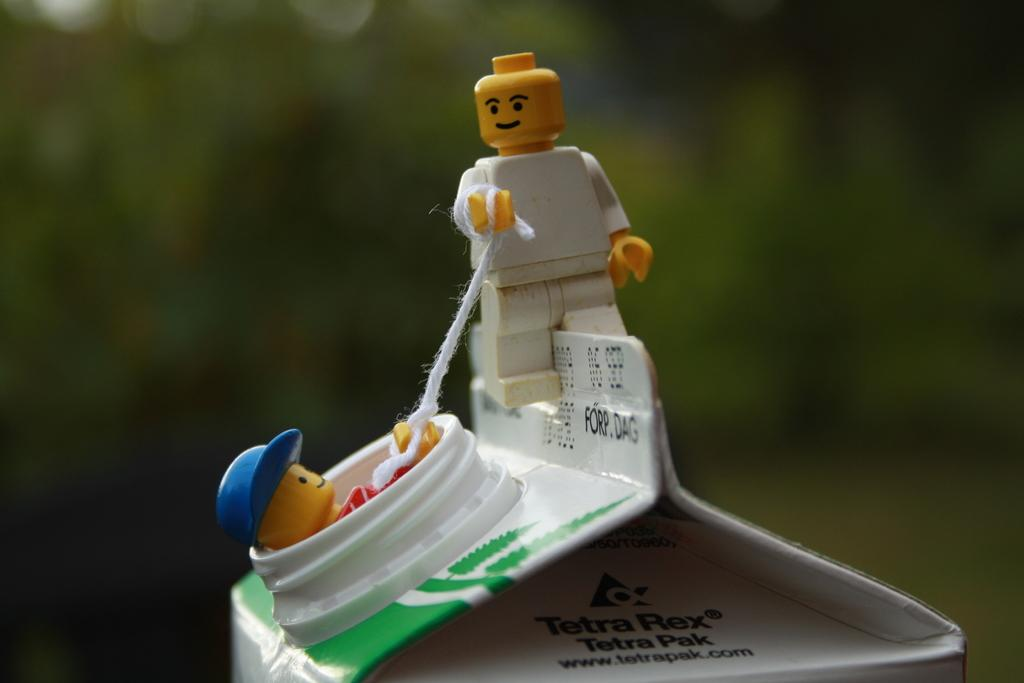What objects can be seen in the image? There are toys in the image. How are the toys connected or arranged? A white color thread is tied to the toys. Are there any labels or identifiers on the thread? Yes, there are names written on the thread. Can you describe the background of the image? The background of the image is blurred. What type of apple can be seen on the sidewalk in the image? There is no apple or sidewalk present in the image; it only features toys with a thread and names. 